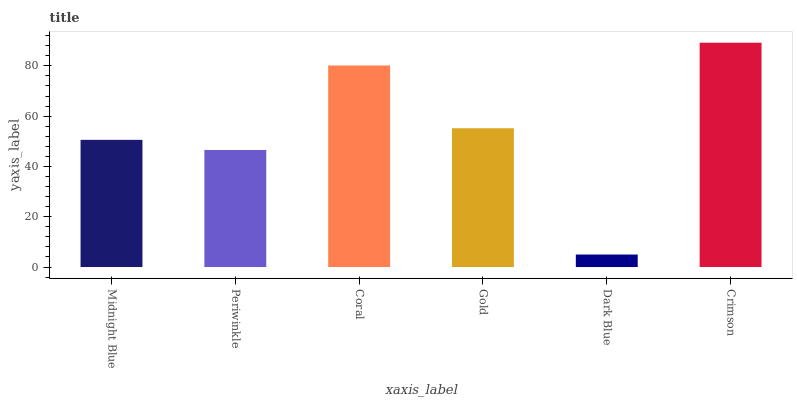Is Dark Blue the minimum?
Answer yes or no. Yes. Is Crimson the maximum?
Answer yes or no. Yes. Is Periwinkle the minimum?
Answer yes or no. No. Is Periwinkle the maximum?
Answer yes or no. No. Is Midnight Blue greater than Periwinkle?
Answer yes or no. Yes. Is Periwinkle less than Midnight Blue?
Answer yes or no. Yes. Is Periwinkle greater than Midnight Blue?
Answer yes or no. No. Is Midnight Blue less than Periwinkle?
Answer yes or no. No. Is Gold the high median?
Answer yes or no. Yes. Is Midnight Blue the low median?
Answer yes or no. Yes. Is Crimson the high median?
Answer yes or no. No. Is Crimson the low median?
Answer yes or no. No. 